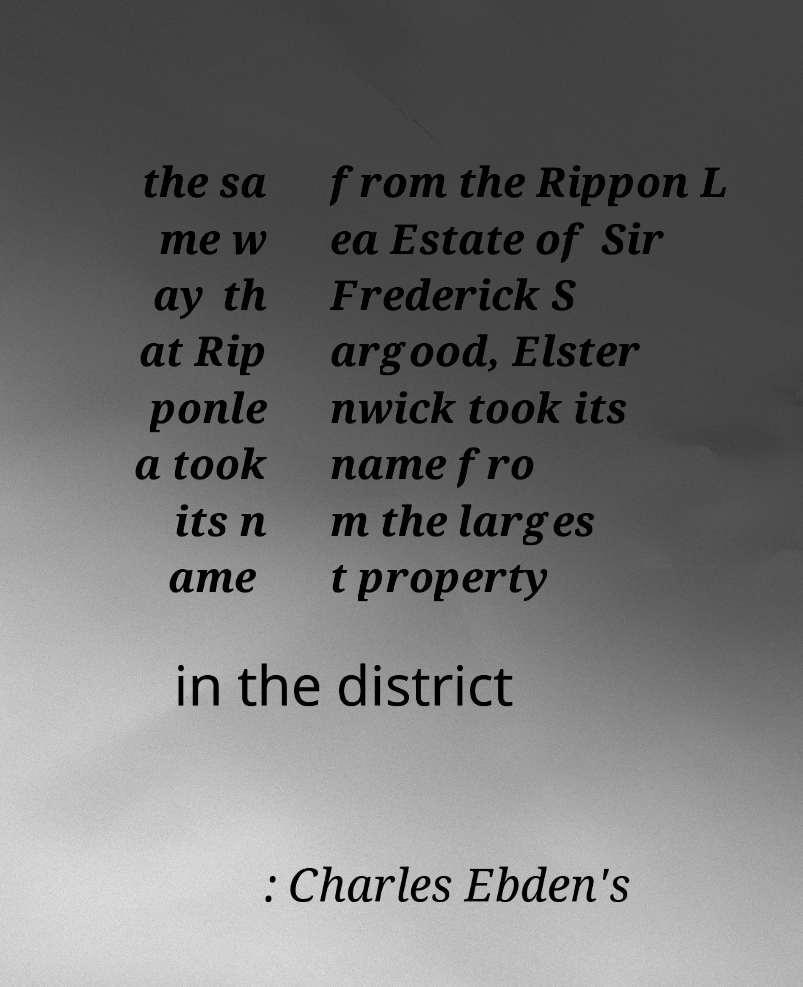Can you accurately transcribe the text from the provided image for me? the sa me w ay th at Rip ponle a took its n ame from the Rippon L ea Estate of Sir Frederick S argood, Elster nwick took its name fro m the larges t property in the district : Charles Ebden's 